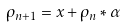Convert formula to latex. <formula><loc_0><loc_0><loc_500><loc_500>\rho _ { n + 1 } = x + \rho _ { n } * \alpha</formula> 